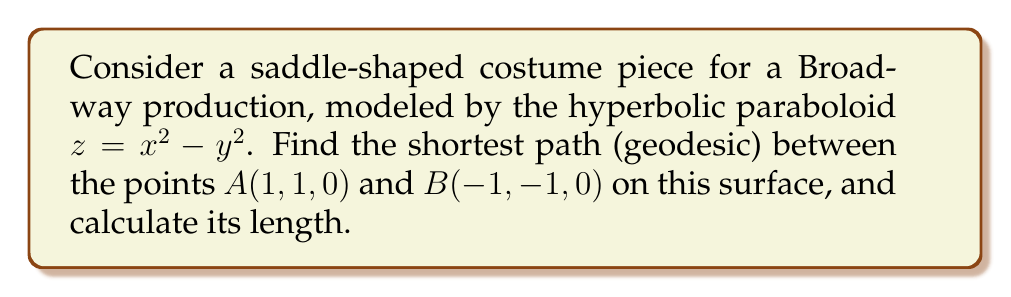Could you help me with this problem? To find the geodesic on a hyperbolic paraboloid, we follow these steps:

1. The hyperbolic paraboloid is given by $z = x^2 - y^2$.

2. For a hyperbolic paraboloid, the geodesics are the intersections of the surface with planes passing through the z-axis. We need to find the equation of such a plane that contains both points A and B.

3. The general equation of a plane passing through the z-axis is:
   $y = mx$, where $m$ is the slope in the xy-plane.

4. Using points A and B, we can find $m$:
   $m = \frac{y_B - y_A}{x_B - x_A} = \frac{-1 - 1}{-1 - 1} = 1$

5. So, the equation of the plane containing the geodesic is:
   $y = x$

6. To find the geodesic, we intersect this plane with the surface:
   $z = x^2 - y^2$ and $y = x$
   Substituting $y$ with $x$:
   $z = x^2 - x^2 = 0$

7. Therefore, the geodesic is the straight line:
   $y = x$ and $z = 0$

8. To calculate the length, we use the distance formula in 3D space:
   $$L = \sqrt{(x_B - x_A)^2 + (y_B - y_A)^2 + (z_B - z_A)^2}$$
   $$L = \sqrt{(-1 - 1)^2 + (-1 - 1)^2 + (0 - 0)^2}$$
   $$L = \sqrt{(-2)^2 + (-2)^2 + 0^2} = \sqrt{8} = 2\sqrt{2}$$

[asy]
import graph3;
size(200);
currentprojection=perspective(6,3,2);

triple f(pair t) {return (t.x,t.y,t.x^2-t.y^2);}
surface s=surface(f,(-2,-2),(2,2),Spline);
draw(s,paleblue);

dot(Label("A",align=N),(1,1,0));
dot(Label("B",align=S),(-1,-1,0));
draw((1,1,0)--(-1,-1,0),red);

xaxis3("x");
yaxis3("y");
zaxis3("z");
[/asy]
Answer: $2\sqrt{2}$ 